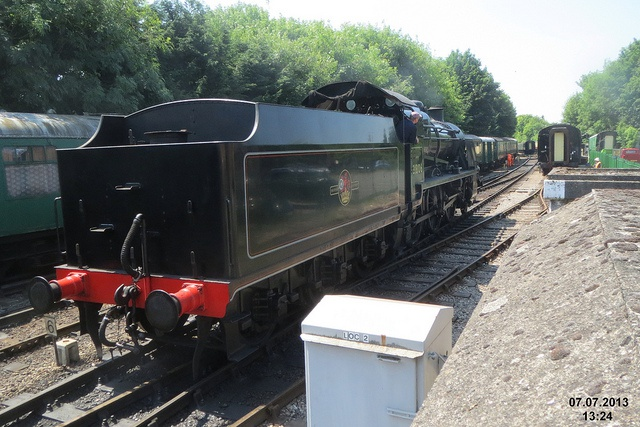Describe the objects in this image and their specific colors. I can see train in darkgreen, black, gray, and brown tones, train in darkgreen, black, gray, purple, and darkgray tones, train in darkgreen, gray, black, darkgray, and purple tones, people in darkgreen, brown, maroon, and salmon tones, and people in darkgreen, white, darkgray, and gray tones in this image. 